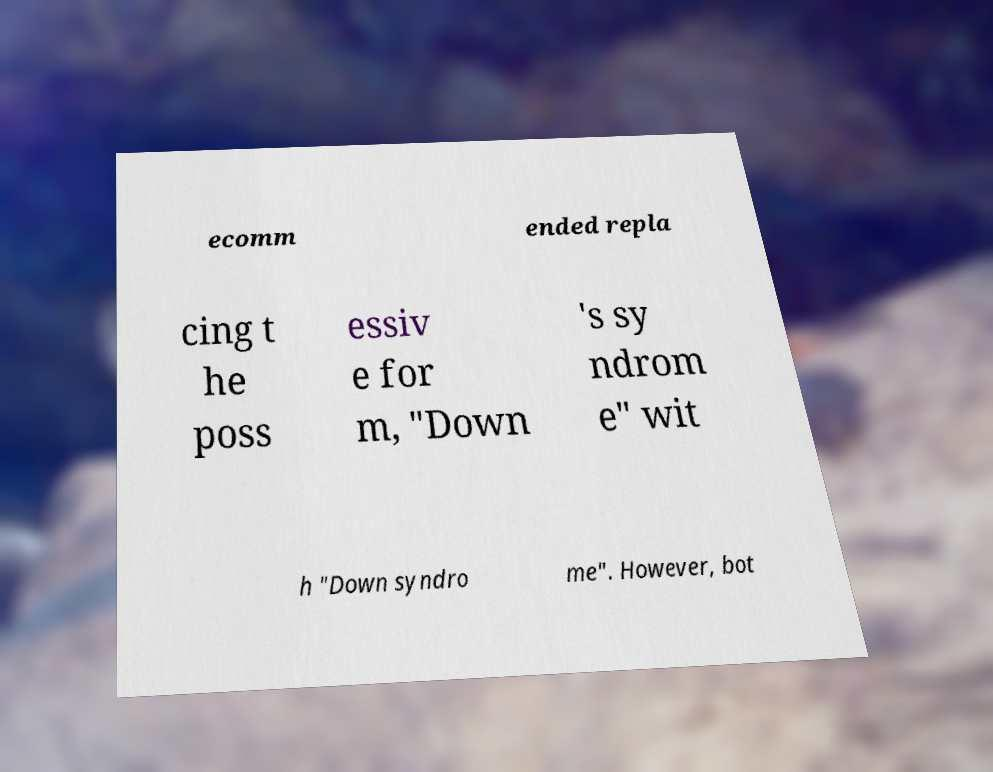Can you accurately transcribe the text from the provided image for me? ecomm ended repla cing t he poss essiv e for m, "Down 's sy ndrom e" wit h "Down syndro me". However, bot 